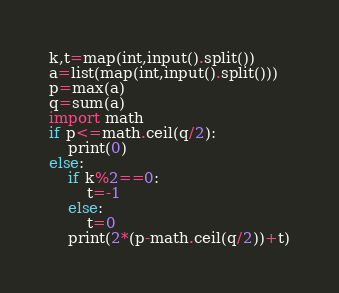Convert code to text. <code><loc_0><loc_0><loc_500><loc_500><_Python_>k,t=map(int,input().split())
a=list(map(int,input().split()))
p=max(a)
q=sum(a)
import math
if p<=math.ceil(q/2):
	print(0)
else:
	if k%2==0:
		t=-1
	else:
		t=0
	print(2*(p-math.ceil(q/2))+t)</code> 